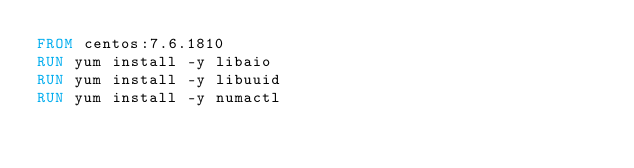Convert code to text. <code><loc_0><loc_0><loc_500><loc_500><_Dockerfile_>FROM centos:7.6.1810
RUN yum install -y libaio
RUN yum install -y libuuid
RUN yum install -y numactl</code> 